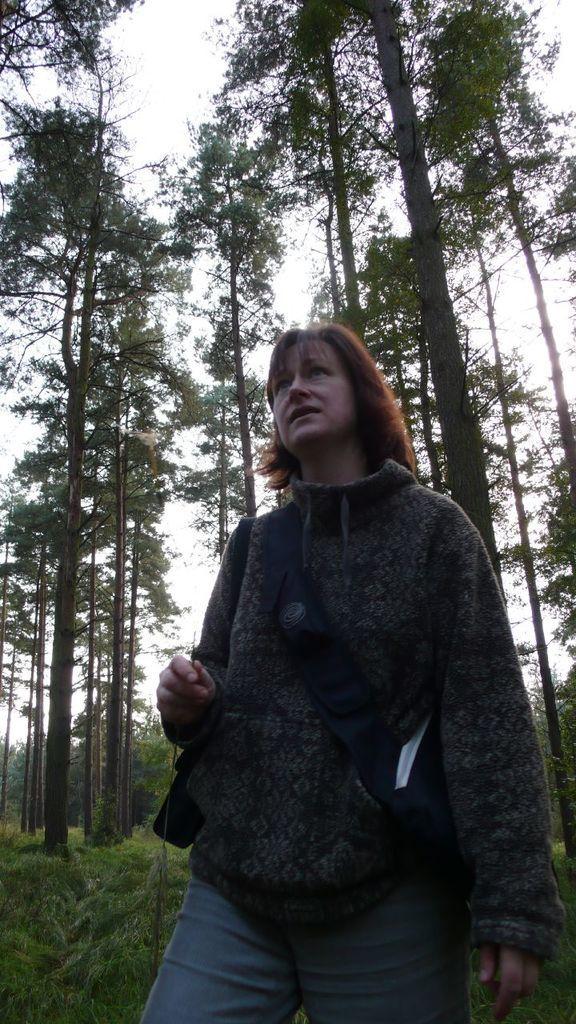Describe this image in one or two sentences. The woman in the middle of the picture wearing a black jacket and blue jeans is standing. Behind her, there are many trees. At the top of the picture, we see the sky. 